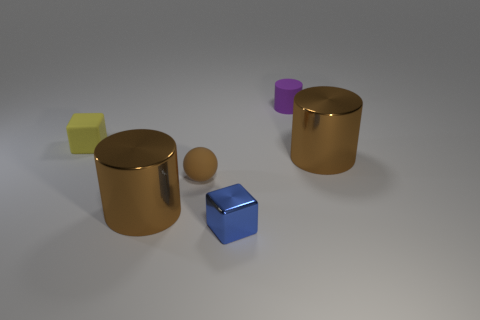Can you describe the texture and color of the objects? Certainly! The objects in the image have notably different textures and colors. The large cylinders and the small sphere have a shiny, reflective texture hinting at a metallic nature, with gold and silver colors respectively. The cube is also reflective, sporting a lustrous blue hue. In contrast, the small cylinder and the block to its left have matte surfaces; the cylinder is purple, and the block is a pastel yellow. 